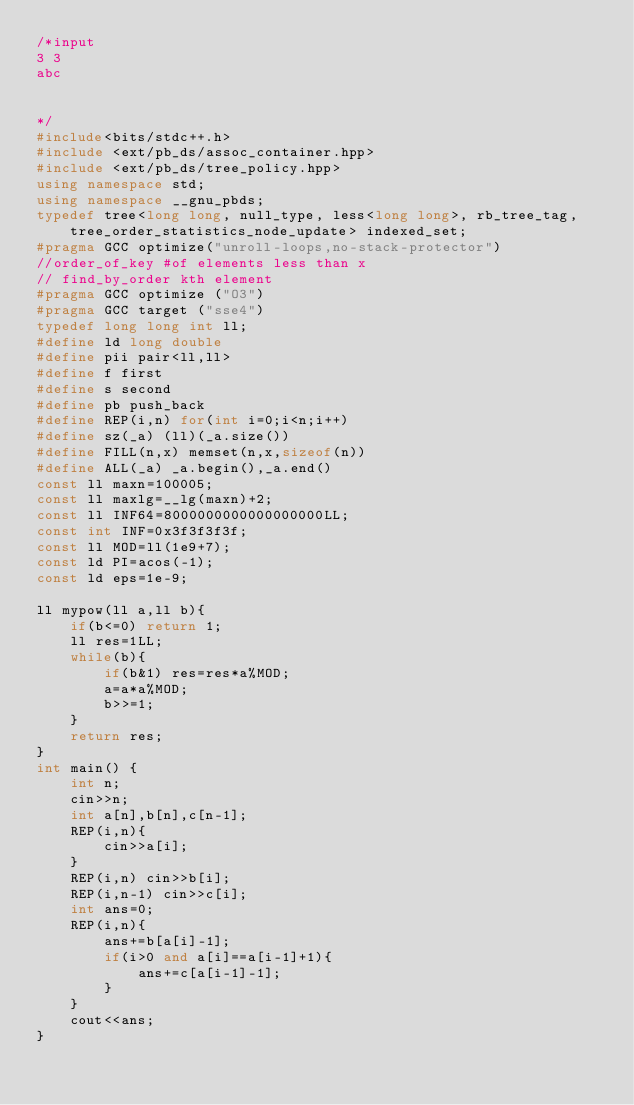<code> <loc_0><loc_0><loc_500><loc_500><_C++_>/*input
3 3
abc


*/
#include<bits/stdc++.h>
#include <ext/pb_ds/assoc_container.hpp>
#include <ext/pb_ds/tree_policy.hpp>
using namespace std;
using namespace __gnu_pbds;
typedef tree<long long, null_type, less<long long>, rb_tree_tag, tree_order_statistics_node_update> indexed_set;
#pragma GCC optimize("unroll-loops,no-stack-protector")
//order_of_key #of elements less than x
// find_by_order kth element
#pragma GCC optimize ("O3")
#pragma GCC target ("sse4")
typedef long long int ll;
#define ld long double
#define pii pair<ll,ll>
#define f first
#define s second
#define pb push_back
#define REP(i,n) for(int i=0;i<n;i++)
#define sz(_a) (ll)(_a.size())
#define FILL(n,x) memset(n,x,sizeof(n))
#define ALL(_a) _a.begin(),_a.end()
const ll maxn=100005;
const ll maxlg=__lg(maxn)+2;
const ll INF64=8000000000000000000LL;
const int INF=0x3f3f3f3f;
const ll MOD=ll(1e9+7);
const ld PI=acos(-1);
const ld eps=1e-9;

ll mypow(ll a,ll b){
    if(b<=0) return 1;
    ll res=1LL;
    while(b){
        if(b&1) res=res*a%MOD;
        a=a*a%MOD;
        b>>=1;
    }
    return res;
}
int main() {
    int n;
    cin>>n;
    int a[n],b[n],c[n-1];
    REP(i,n){
    	cin>>a[i];
    }
    REP(i,n) cin>>b[i];
    REP(i,n-1) cin>>c[i];
    int ans=0;
    REP(i,n){
    	ans+=b[a[i]-1];
    	if(i>0 and a[i]==a[i-1]+1){
    		ans+=c[a[i-1]-1];
    	}
    }
    cout<<ans;
}</code> 